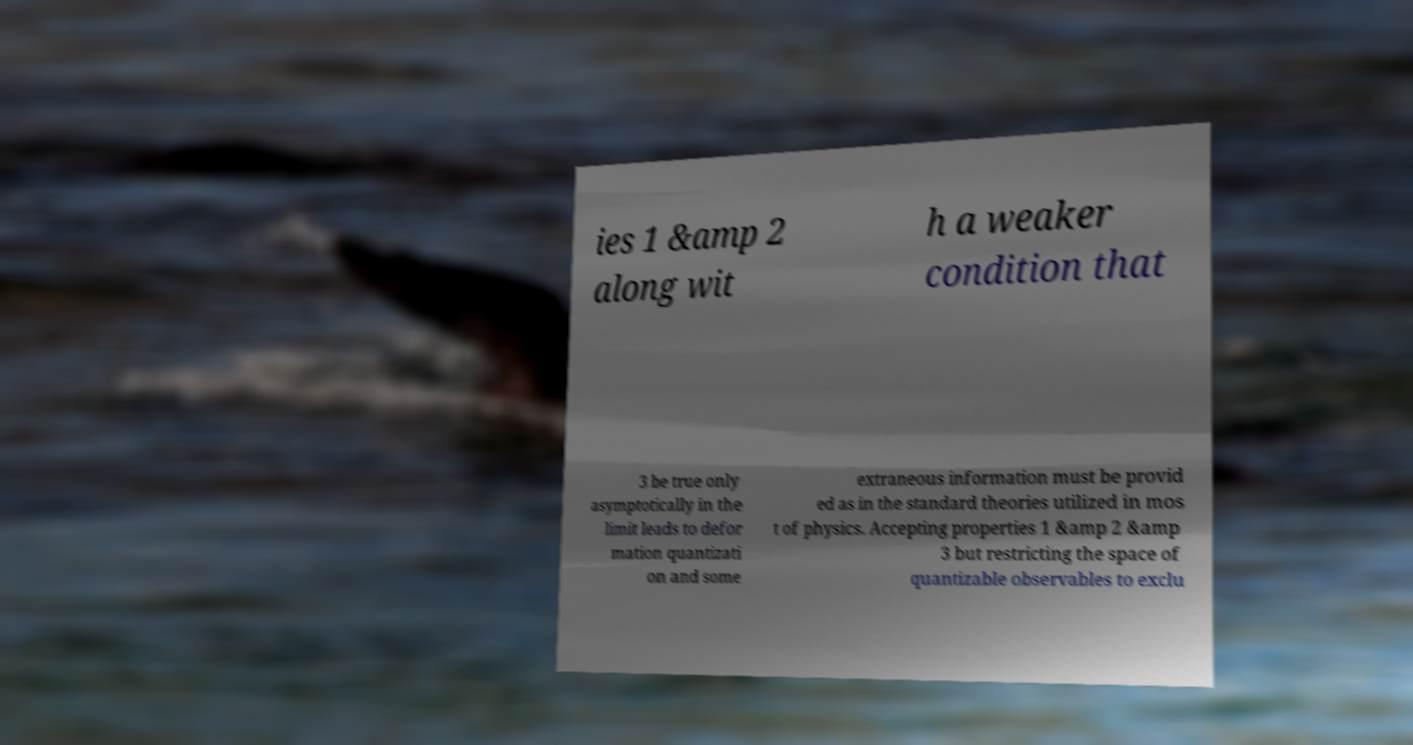Please identify and transcribe the text found in this image. ies 1 &amp 2 along wit h a weaker condition that 3 be true only asymptotically in the limit leads to defor mation quantizati on and some extraneous information must be provid ed as in the standard theories utilized in mos t of physics. Accepting properties 1 &amp 2 &amp 3 but restricting the space of quantizable observables to exclu 